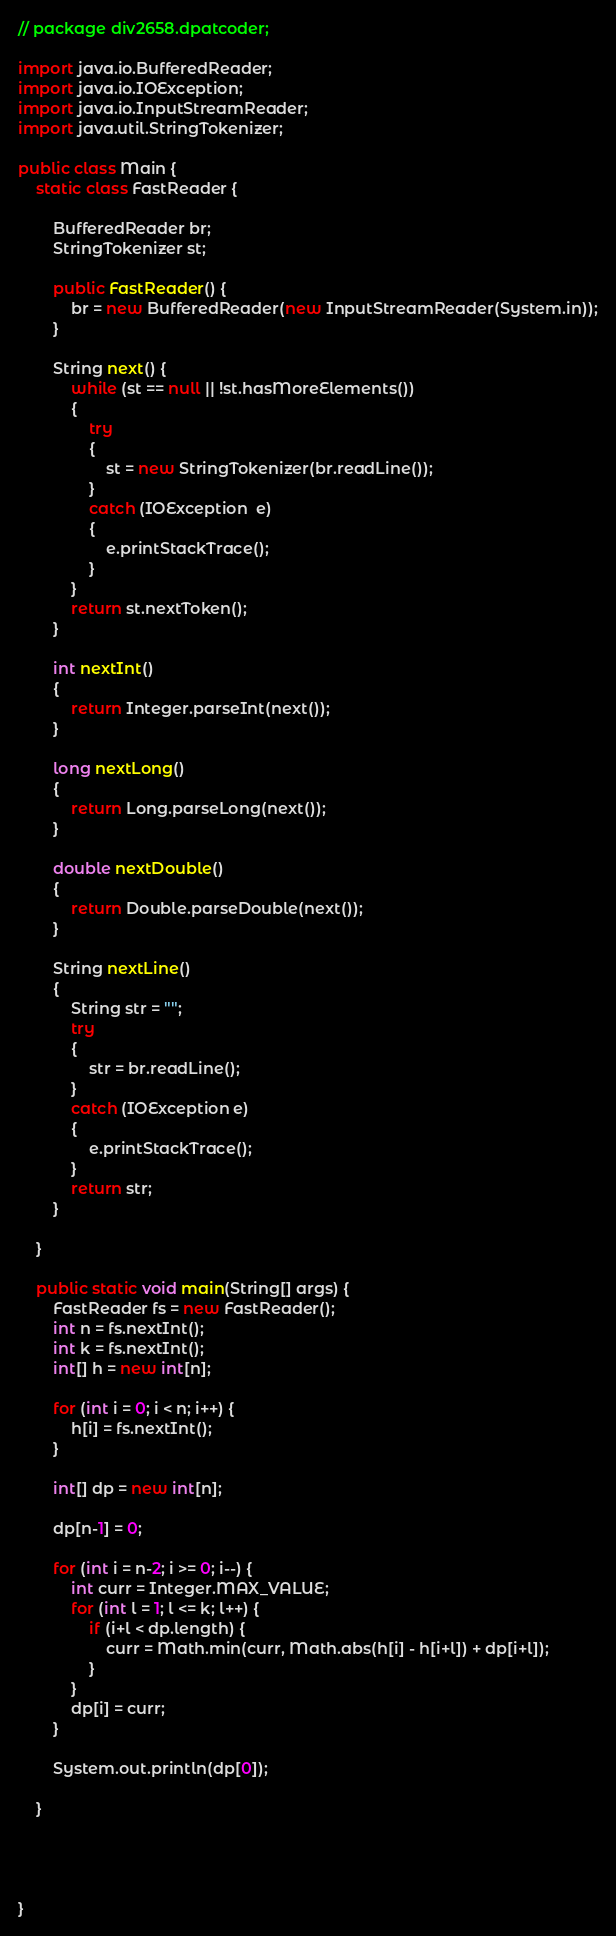Convert code to text. <code><loc_0><loc_0><loc_500><loc_500><_Java_>// package div2658.dpatcoder;

import java.io.BufferedReader;
import java.io.IOException;
import java.io.InputStreamReader;
import java.util.StringTokenizer;

public class Main {
    static class FastReader {

        BufferedReader br;
        StringTokenizer st;

        public FastReader() {
            br = new BufferedReader(new InputStreamReader(System.in));
        }

        String next() {
            while (st == null || !st.hasMoreElements()) 
            { 
                try
                { 
                    st = new StringTokenizer(br.readLine()); 
                } 
                catch (IOException  e) 
                { 
                    e.printStackTrace(); 
                } 
            } 
            return st.nextToken(); 
        }

        int nextInt() 
        { 
            return Integer.parseInt(next()); 
        } 
  
        long nextLong() 
        { 
            return Long.parseLong(next()); 
        } 
  
        double nextDouble() 
        { 
            return Double.parseDouble(next()); 
        }

        String nextLine() 
        { 
            String str = ""; 
            try
            { 
                str = br.readLine(); 
            } 
            catch (IOException e) 
            { 
                e.printStackTrace(); 
            } 
            return str; 
        } 

    }

    public static void main(String[] args) {
        FastReader fs = new FastReader();
        int n = fs.nextInt();
        int k = fs.nextInt();
        int[] h = new int[n];
        
        for (int i = 0; i < n; i++) {
            h[i] = fs.nextInt();
        }

        int[] dp = new int[n];

        dp[n-1] = 0;

        for (int i = n-2; i >= 0; i--) {
            int curr = Integer.MAX_VALUE;
            for (int l = 1; l <= k; l++) {
                if (i+l < dp.length) {
                    curr = Math.min(curr, Math.abs(h[i] - h[i+l]) + dp[i+l]);
                }
            }
            dp[i] = curr;
        }

        System.out.println(dp[0]);

    }




}
</code> 